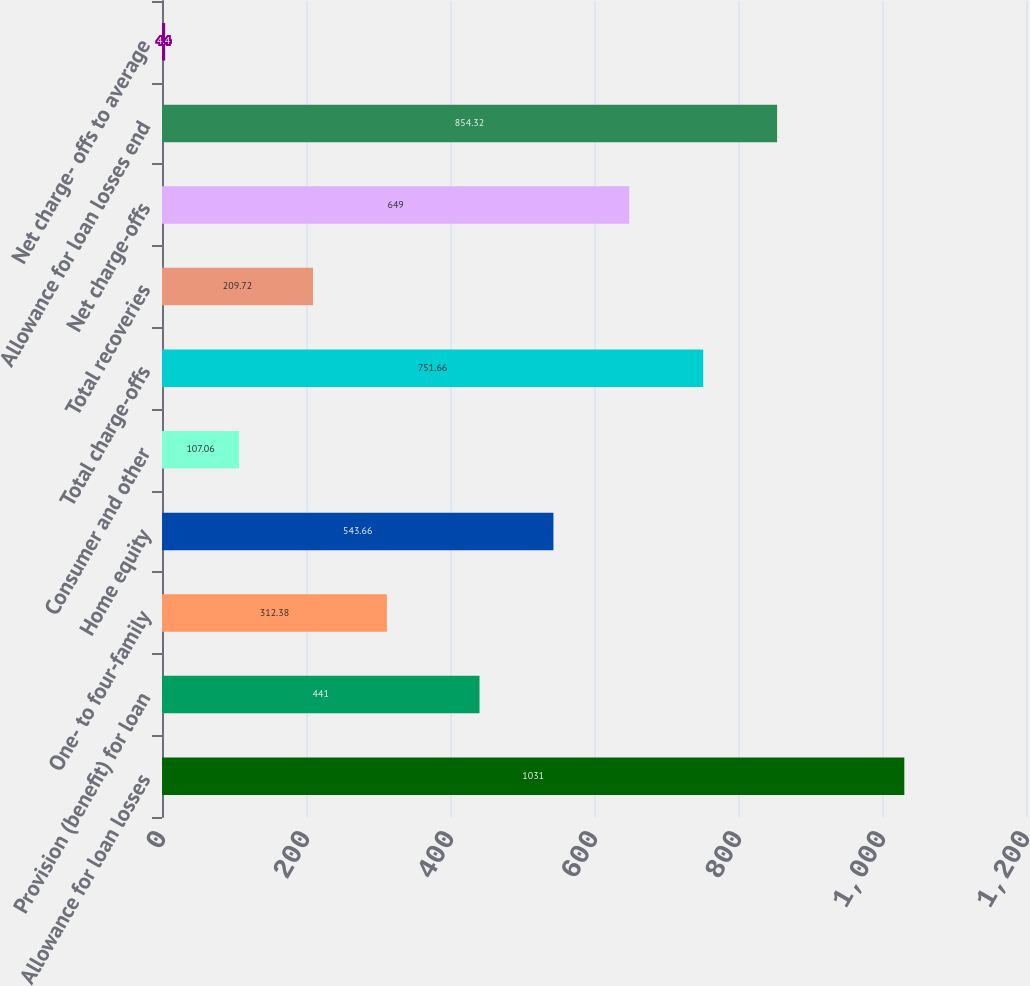Convert chart. <chart><loc_0><loc_0><loc_500><loc_500><bar_chart><fcel>Allowance for loan losses<fcel>Provision (benefit) for loan<fcel>One- to four-family<fcel>Home equity<fcel>Consumer and other<fcel>Total charge-offs<fcel>Total recoveries<fcel>Net charge-offs<fcel>Allowance for loan losses end<fcel>Net charge- offs to average<nl><fcel>1031<fcel>441<fcel>312.38<fcel>543.66<fcel>107.06<fcel>751.66<fcel>209.72<fcel>649<fcel>854.32<fcel>4.4<nl></chart> 